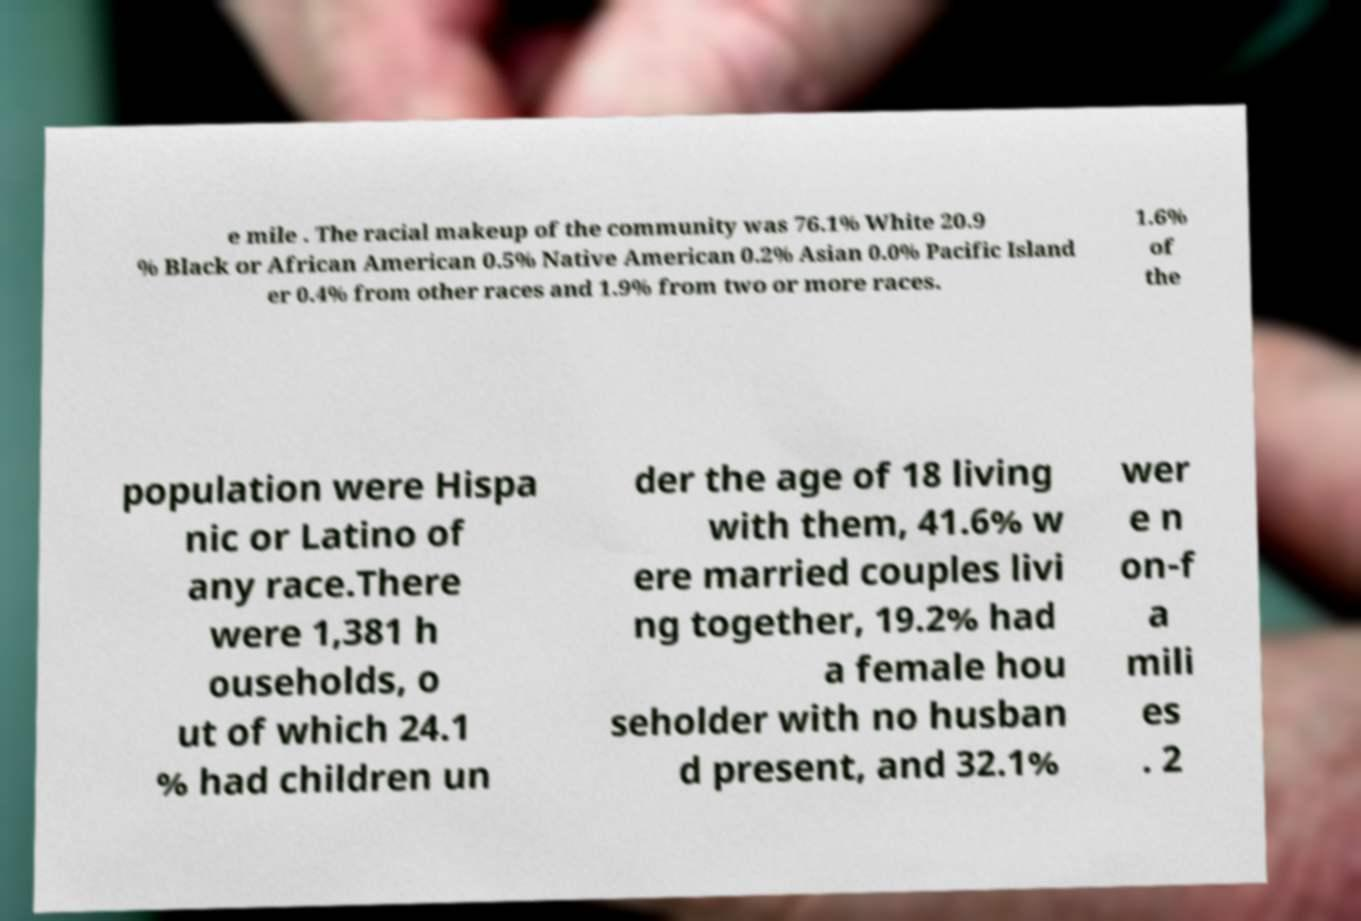Could you assist in decoding the text presented in this image and type it out clearly? e mile . The racial makeup of the community was 76.1% White 20.9 % Black or African American 0.5% Native American 0.2% Asian 0.0% Pacific Island er 0.4% from other races and 1.9% from two or more races. 1.6% of the population were Hispa nic or Latino of any race.There were 1,381 h ouseholds, o ut of which 24.1 % had children un der the age of 18 living with them, 41.6% w ere married couples livi ng together, 19.2% had a female hou seholder with no husban d present, and 32.1% wer e n on-f a mili es . 2 